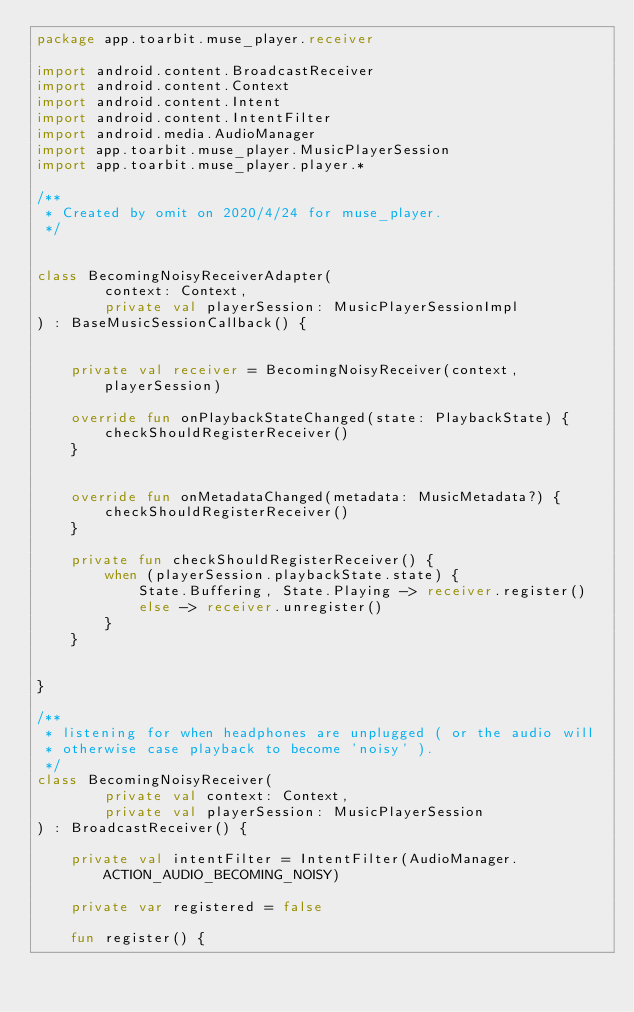Convert code to text. <code><loc_0><loc_0><loc_500><loc_500><_Kotlin_>package app.toarbit.muse_player.receiver

import android.content.BroadcastReceiver
import android.content.Context
import android.content.Intent
import android.content.IntentFilter
import android.media.AudioManager
import app.toarbit.muse_player.MusicPlayerSession
import app.toarbit.muse_player.player.*

/**
 * Created by omit on 2020/4/24 for muse_player.
 */


class BecomingNoisyReceiverAdapter(
        context: Context,
        private val playerSession: MusicPlayerSessionImpl
) : BaseMusicSessionCallback() {


    private val receiver = BecomingNoisyReceiver(context, playerSession)

    override fun onPlaybackStateChanged(state: PlaybackState) {
        checkShouldRegisterReceiver()
    }


    override fun onMetadataChanged(metadata: MusicMetadata?) {
        checkShouldRegisterReceiver()
    }

    private fun checkShouldRegisterReceiver() {
        when (playerSession.playbackState.state) {
            State.Buffering, State.Playing -> receiver.register()
            else -> receiver.unregister()
        }
    }


}

/**
 * listening for when headphones are unplugged ( or the audio will
 * otherwise case playback to become 'noisy' ).
 */
class BecomingNoisyReceiver(
        private val context: Context,
        private val playerSession: MusicPlayerSession
) : BroadcastReceiver() {

    private val intentFilter = IntentFilter(AudioManager.ACTION_AUDIO_BECOMING_NOISY)

    private var registered = false

    fun register() {</code> 